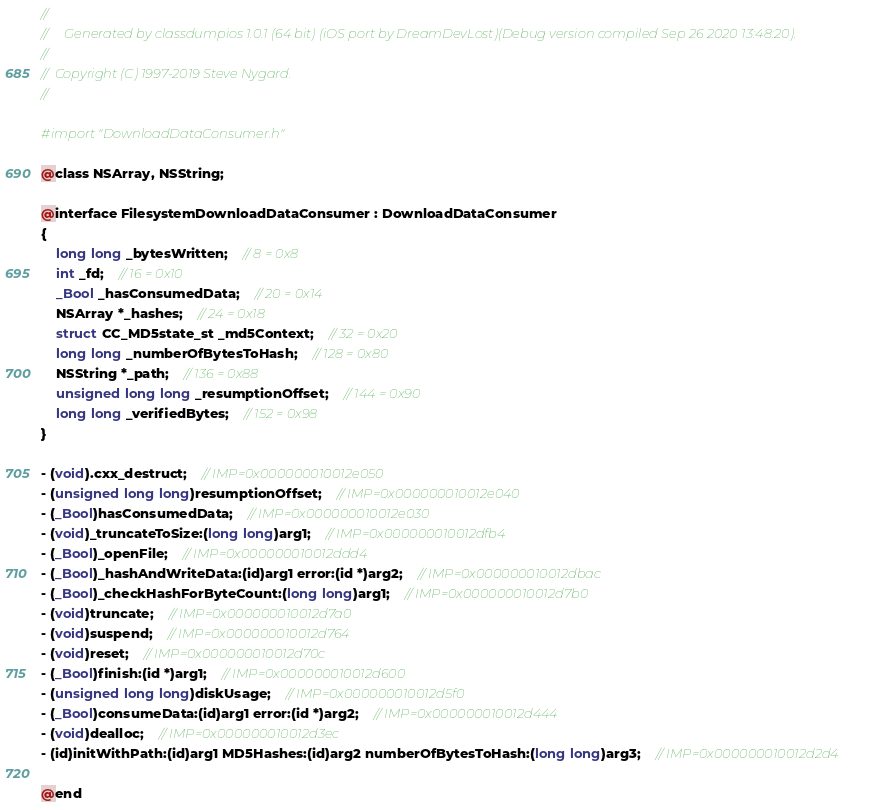<code> <loc_0><loc_0><loc_500><loc_500><_C_>//
//     Generated by classdumpios 1.0.1 (64 bit) (iOS port by DreamDevLost)(Debug version compiled Sep 26 2020 13:48:20).
//
//  Copyright (C) 1997-2019 Steve Nygard.
//

#import "DownloadDataConsumer.h"

@class NSArray, NSString;

@interface FilesystemDownloadDataConsumer : DownloadDataConsumer
{
    long long _bytesWritten;	// 8 = 0x8
    int _fd;	// 16 = 0x10
    _Bool _hasConsumedData;	// 20 = 0x14
    NSArray *_hashes;	// 24 = 0x18
    struct CC_MD5state_st _md5Context;	// 32 = 0x20
    long long _numberOfBytesToHash;	// 128 = 0x80
    NSString *_path;	// 136 = 0x88
    unsigned long long _resumptionOffset;	// 144 = 0x90
    long long _verifiedBytes;	// 152 = 0x98
}

- (void).cxx_destruct;	// IMP=0x000000010012e050
- (unsigned long long)resumptionOffset;	// IMP=0x000000010012e040
- (_Bool)hasConsumedData;	// IMP=0x000000010012e030
- (void)_truncateToSize:(long long)arg1;	// IMP=0x000000010012dfb4
- (_Bool)_openFile;	// IMP=0x000000010012ddd4
- (_Bool)_hashAndWriteData:(id)arg1 error:(id *)arg2;	// IMP=0x000000010012dbac
- (_Bool)_checkHashForByteCount:(long long)arg1;	// IMP=0x000000010012d7b0
- (void)truncate;	// IMP=0x000000010012d7a0
- (void)suspend;	// IMP=0x000000010012d764
- (void)reset;	// IMP=0x000000010012d70c
- (_Bool)finish:(id *)arg1;	// IMP=0x000000010012d600
- (unsigned long long)diskUsage;	// IMP=0x000000010012d5f0
- (_Bool)consumeData:(id)arg1 error:(id *)arg2;	// IMP=0x000000010012d444
- (void)dealloc;	// IMP=0x000000010012d3ec
- (id)initWithPath:(id)arg1 MD5Hashes:(id)arg2 numberOfBytesToHash:(long long)arg3;	// IMP=0x000000010012d2d4

@end

</code> 